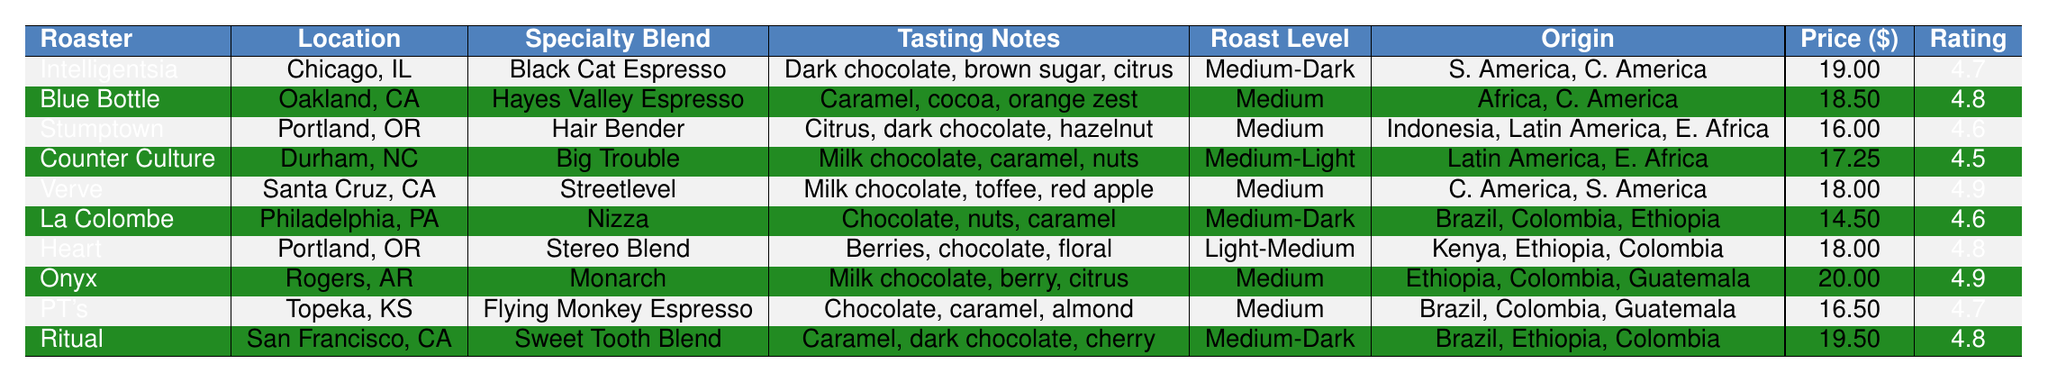What is the price of the Black Cat Espresso? The table shows that the price for the Black Cat Espresso is listed under the "Price" column for "Intelligentsia Coffee," which is $19.00.
Answer: $19.00 Which roaster has the highest customer rating? By comparing the "Customer Rating" column, the highest rating is 4.9, which appears for both Verve Coffee Roasters and Onyx Coffee Lab.
Answer: Verve Coffee Roasters and Onyx Coffee Lab Is the Hayes Valley Espresso organic? The table indicates that the Hayes Valley Espresso, produced by Blue Bottle Coffee, is marked as not organic (false under the "Organic" column).
Answer: No What roast level is the Flying Monkey Espresso? The table shows that the Flying Monkey Espresso, from PT's Coffee Roasting Co., has a roast level of Medium.
Answer: Medium How many specialty blends are rated 4.8 or higher? By counting the entries in the "Rating" column that are 4.8 or higher, we find that there are five blends: Hayes Valley Espresso, Verve Coffee Roasters, Heart Coffee Roasters, Onyx Coffee Lab, and Sweet Tooth Blend.
Answer: 5 What is the average price of the specialty blends that are organic? We look at the blends marked as organic (Black Cat Espresso, Hair Bender, Streetlevel, Stereo Blend, Monarch, and Sweet Tooth Blend) with prices $19.00, $16.00, $18.00, $18.00, $20.00, and $19.50. The total price is $110.50, and since there are 6 organic blends, the average price is $110.50 / 6 = $18.42.
Answer: $18.42 Which specialty blend has tasting notes that include chocolate and is a dark roast? The table shows that both the Black Cat Espresso and Flying Monkey Espresso have tasting notes of chocolate and fall under Medium-Dark roast level.
Answer: Black Cat Espresso and Flying Monkey Espresso How many roasters have coffee blends that originate from Ethiopia? By examining the "Origin" column, we find that Heart Coffee Roasters, Onyx Coffee Lab, and Ritual Coffee Roasters have blends that originate from Ethiopia, totaling three roasters.
Answer: 3 What is the price difference between the most expensive and least expensive blends? The most expensive blend is Monarch at $20.00 and the least expensive is Nizza at $14.50. The price difference is $20.00 - $14.50 = $5.50.
Answer: $5.50 Which roaster has a specialty blend with the highest tasting note complexity? The tasting notes for blends like Hair Bender (Citrus, dark chocolate, hazelnut) and Stereo Blend (Berries, chocolate, floral) seem complex. Both are from Stumptown Coffee Roasters and Heart Coffee Roasters respectively and are rated equally, indicating the roasters have diverse tasting notes.
Answer: Stumptown Coffee Roasters and Heart Coffee Roasters 